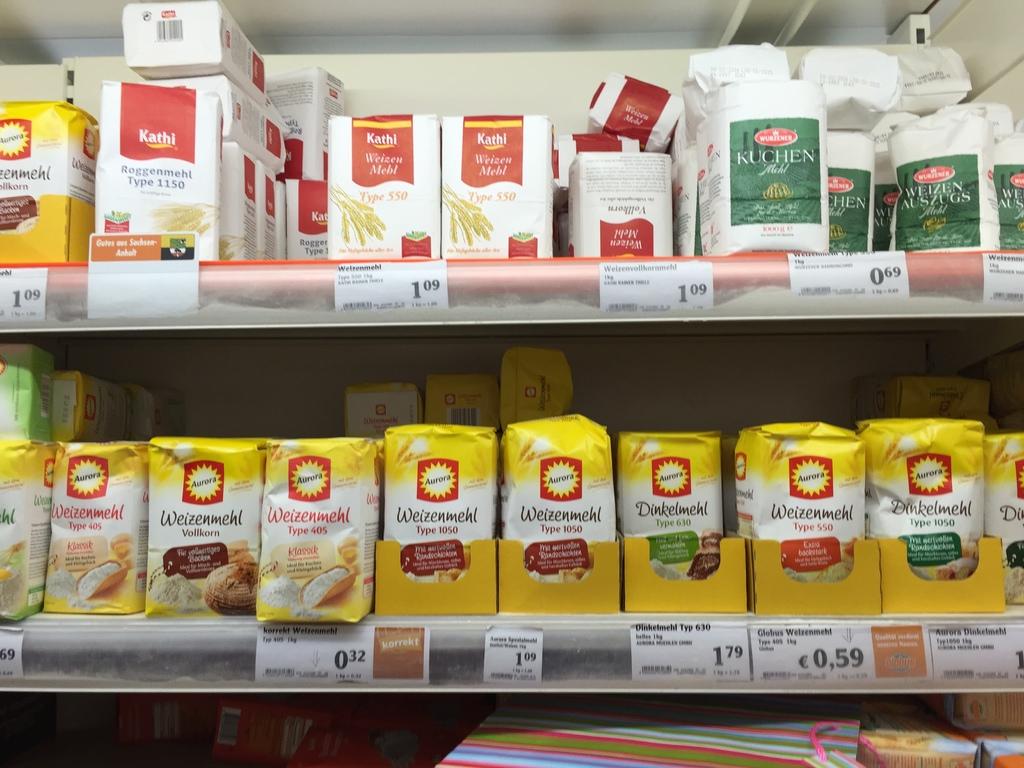What is the price of the top right object?
Give a very brief answer. 0.69. 